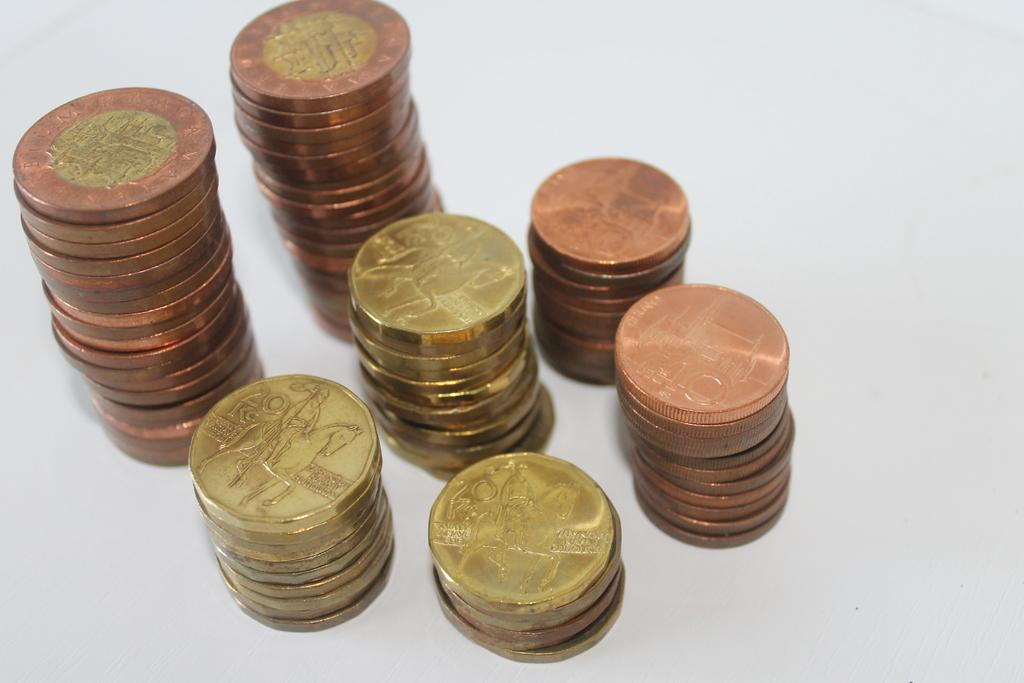<image>
Offer a succinct explanation of the picture presented. Stacks of different coins and some have 20 on them 